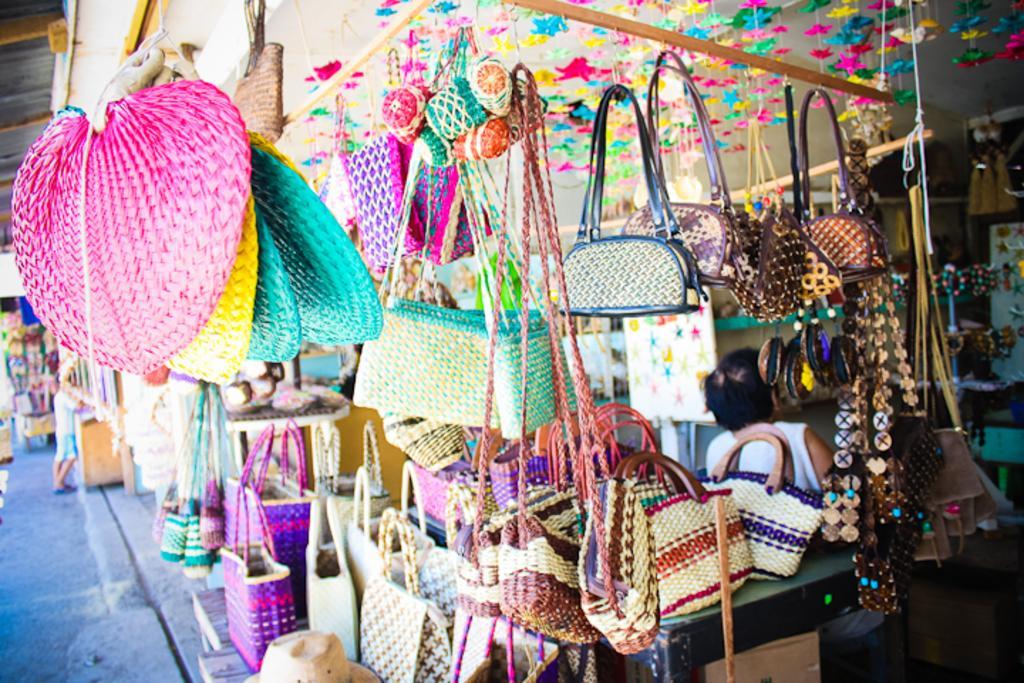Could you give a brief overview of what you see in this image? In this image we can see a store. There are many objects are placed in a store. A person is standing at the left side of the image. 